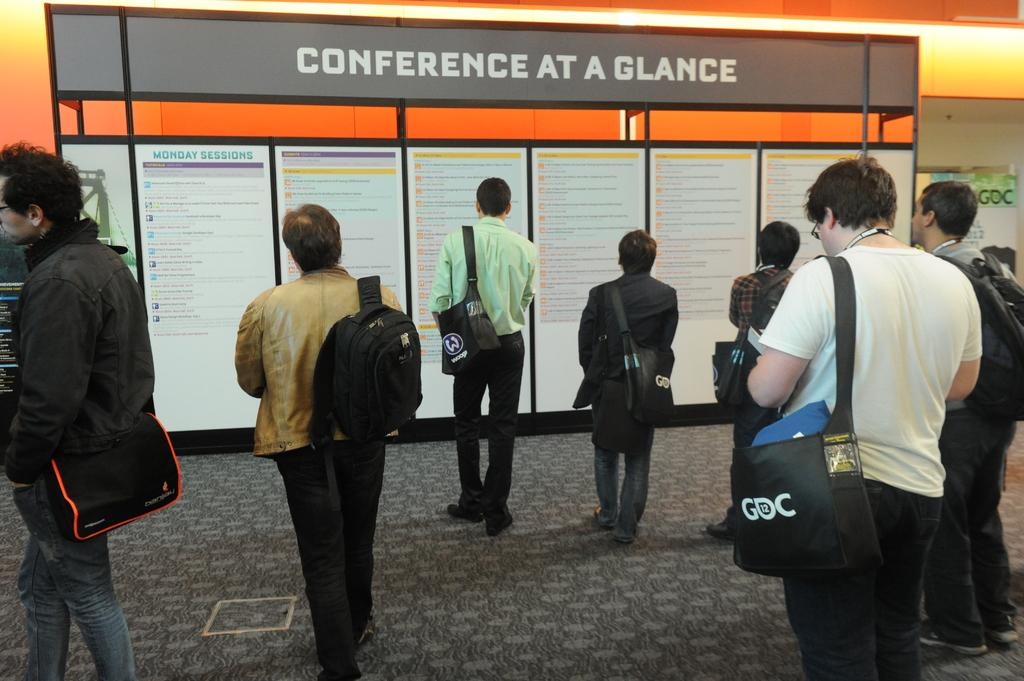How many people are in the image? There is a group of people in the image, but the exact number is not specified. What are the people doing in the image? The people are standing and carrying bags. What can be seen in the background of the image? There is a board in the background of the image. What is written on the board? The board has names written on it. What type of gun is being distributed at the hour specified on the board? There is no mention of a gun or any distribution in the image. The board has names written on it, but no hour or distribution is mentioned. 